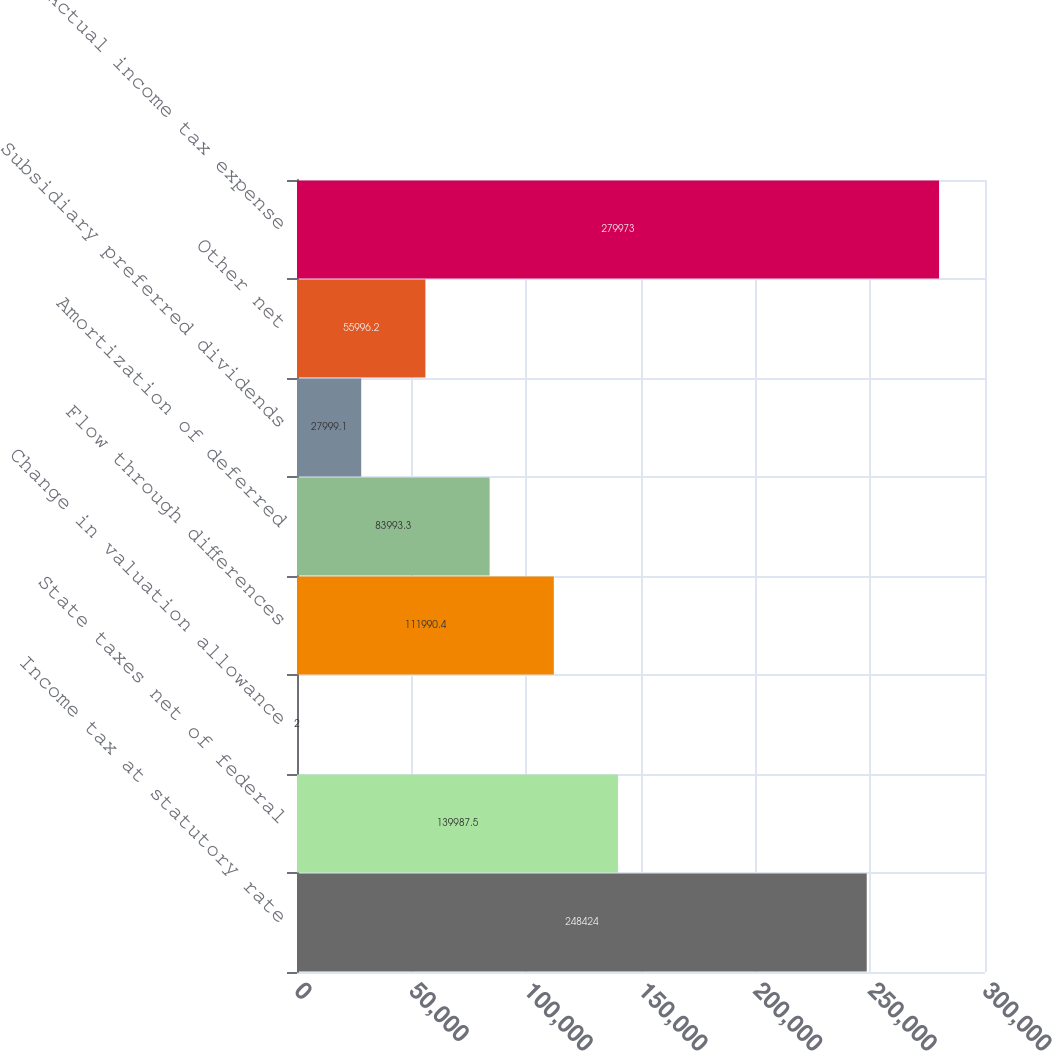Convert chart. <chart><loc_0><loc_0><loc_500><loc_500><bar_chart><fcel>Income tax at statutory rate<fcel>State taxes net of federal<fcel>Change in valuation allowance<fcel>Flow through differences<fcel>Amortization of deferred<fcel>Subsidiary preferred dividends<fcel>Other net<fcel>Actual income tax expense<nl><fcel>248424<fcel>139988<fcel>2<fcel>111990<fcel>83993.3<fcel>27999.1<fcel>55996.2<fcel>279973<nl></chart> 